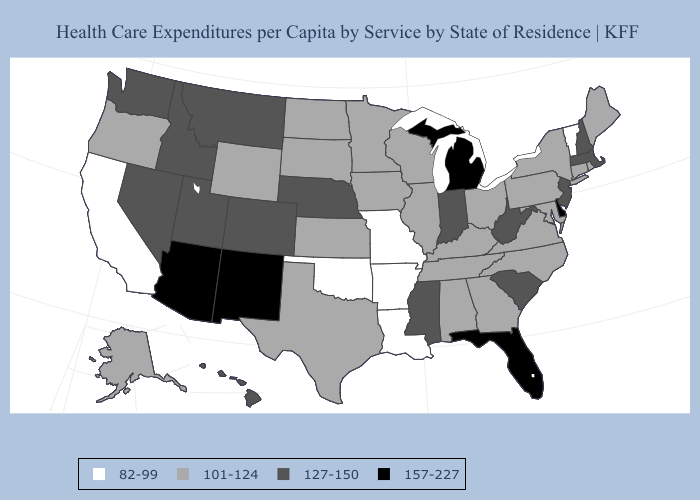Name the states that have a value in the range 101-124?
Quick response, please. Alabama, Alaska, Connecticut, Georgia, Illinois, Iowa, Kansas, Kentucky, Maine, Maryland, Minnesota, New York, North Carolina, North Dakota, Ohio, Oregon, Pennsylvania, Rhode Island, South Dakota, Tennessee, Texas, Virginia, Wisconsin, Wyoming. Among the states that border Tennessee , which have the lowest value?
Answer briefly. Arkansas, Missouri. Does Missouri have the lowest value in the USA?
Quick response, please. Yes. What is the lowest value in states that border Missouri?
Keep it brief. 82-99. Name the states that have a value in the range 82-99?
Concise answer only. Arkansas, California, Louisiana, Missouri, Oklahoma, Vermont. Which states have the lowest value in the USA?
Quick response, please. Arkansas, California, Louisiana, Missouri, Oklahoma, Vermont. What is the value of Oklahoma?
Quick response, please. 82-99. Does California have the lowest value in the West?
Short answer required. Yes. Does Connecticut have the highest value in the Northeast?
Be succinct. No. What is the value of Arizona?
Keep it brief. 157-227. Which states hav the highest value in the Northeast?
Keep it brief. Massachusetts, New Hampshire, New Jersey. Does California have the lowest value in the West?
Answer briefly. Yes. What is the lowest value in the USA?
Concise answer only. 82-99. Does Missouri have the same value as Wyoming?
Short answer required. No. Name the states that have a value in the range 157-227?
Quick response, please. Arizona, Delaware, Florida, Michigan, New Mexico. 